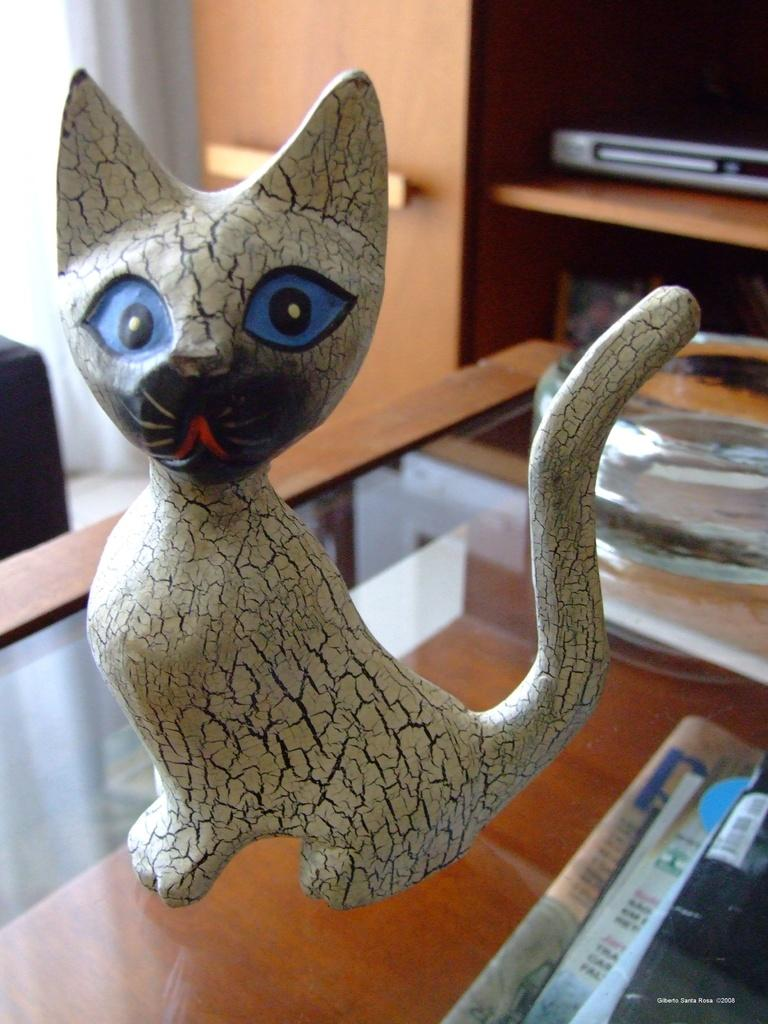What is the main subject on the table in the image? There is a cat sculpture on the table. Where is the DVD player located in the image? The DVD player is on a shelf in a cupboard. What can be found below the table in the image? There are files and papers below the table. How many tails does the cat sculpture have in the image? The cat sculpture is not a real cat, so it does not have a tail. What part of the brain can be seen in the image? There is no brain visible in the image. 